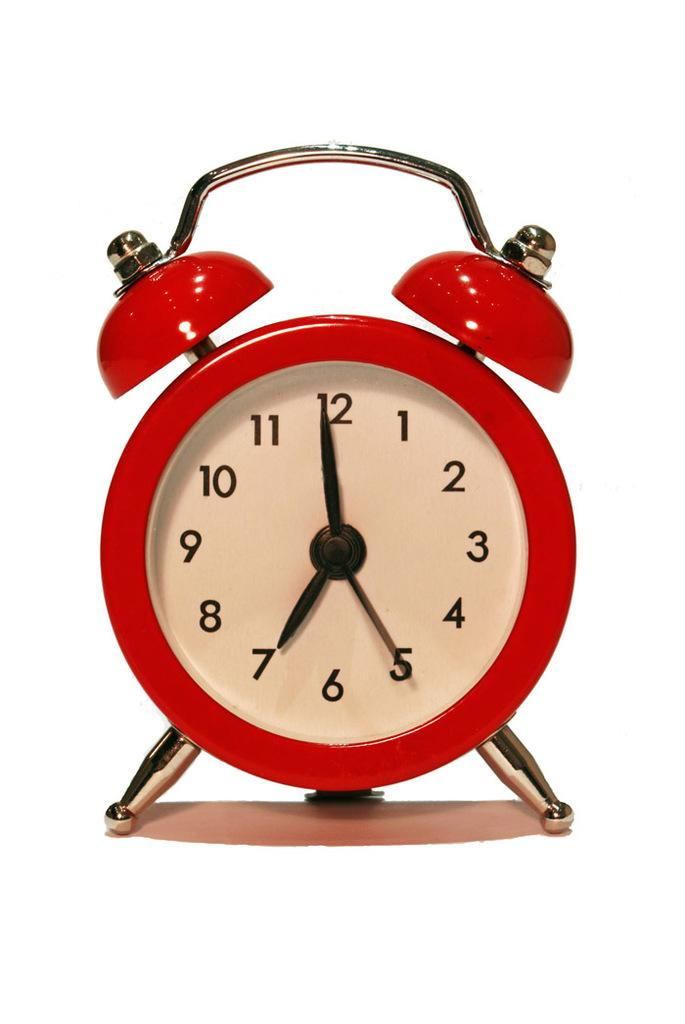<image>
Provide a brief description of the given image. A red alarm clock set to almost 7 o'clock 